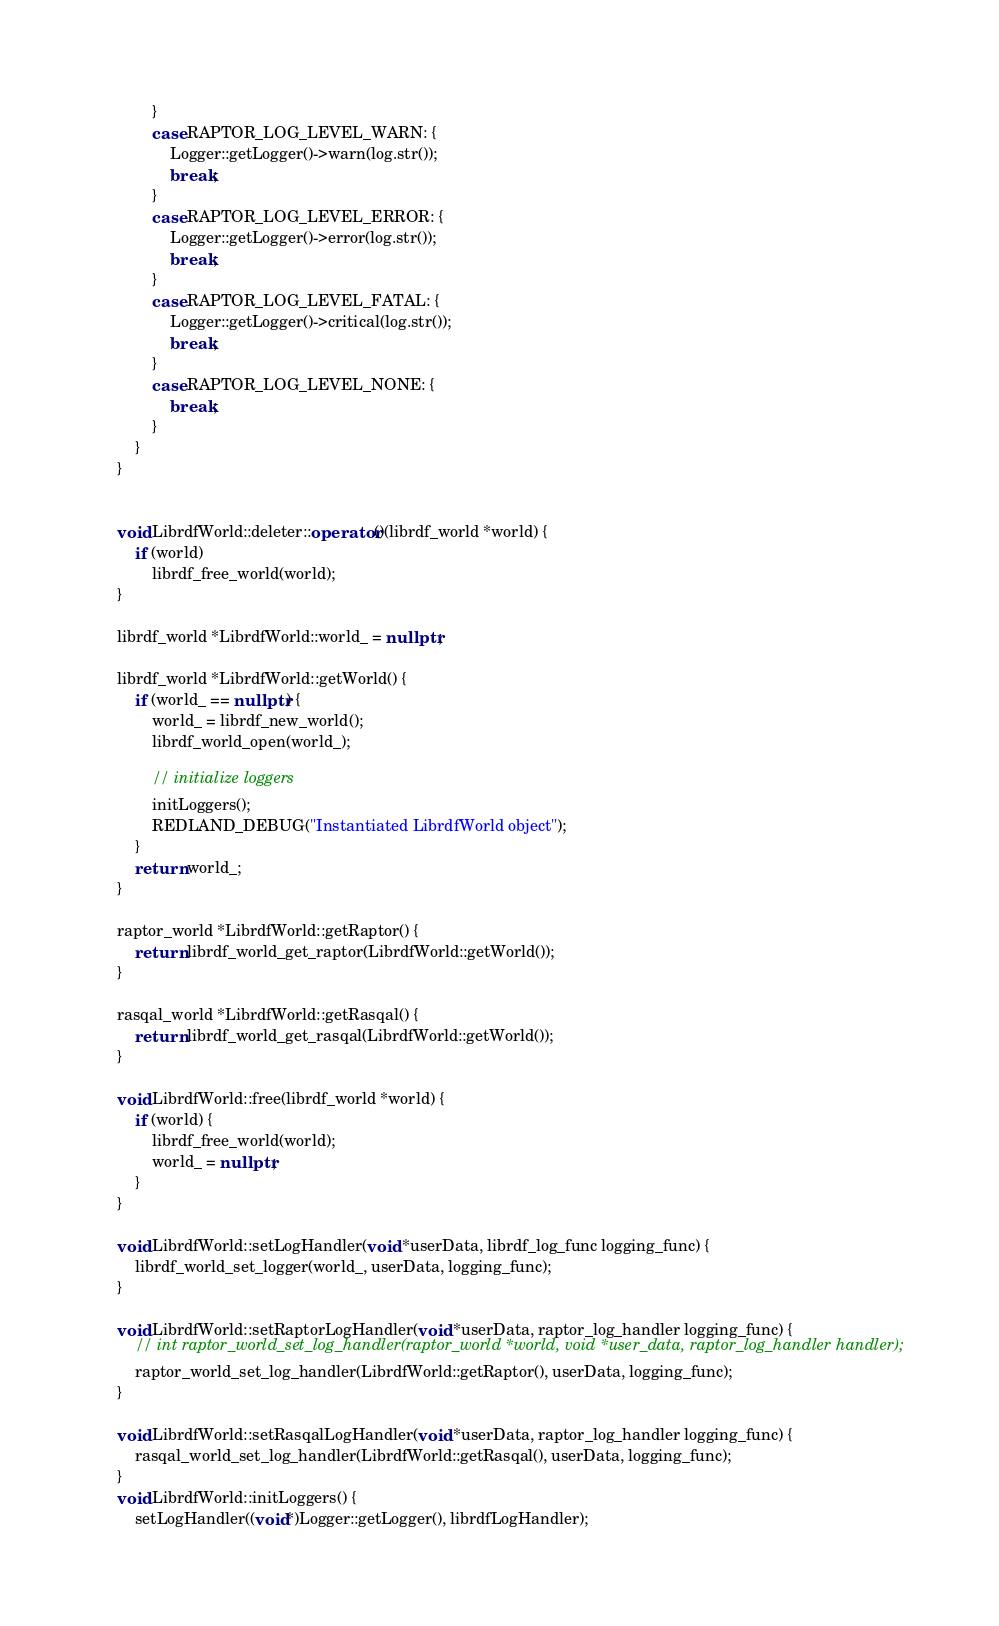Convert code to text. <code><loc_0><loc_0><loc_500><loc_500><_C++_>            }
            case RAPTOR_LOG_LEVEL_WARN: {
                Logger::getLogger()->warn(log.str());
                break;
            }
            case RAPTOR_LOG_LEVEL_ERROR: {
                Logger::getLogger()->error(log.str());
                break;
            }
            case RAPTOR_LOG_LEVEL_FATAL: {
                Logger::getLogger()->critical(log.str());
                break;
            }
            case RAPTOR_LOG_LEVEL_NONE: {
                break;
            }
        }
    }


    void LibrdfWorld::deleter::operator()(librdf_world *world) {
        if (world)
            librdf_free_world(world);
    }

    librdf_world *LibrdfWorld::world_ = nullptr;

    librdf_world *LibrdfWorld::getWorld() {
        if (world_ == nullptr) {
            world_ = librdf_new_world();
            librdf_world_open(world_);

            // initialize loggers
            initLoggers();
            REDLAND_DEBUG("Instantiated LibrdfWorld object");
        }
        return world_;
    }

    raptor_world *LibrdfWorld::getRaptor() {
        return librdf_world_get_raptor(LibrdfWorld::getWorld());
    }

    rasqal_world *LibrdfWorld::getRasqal() {
        return librdf_world_get_rasqal(LibrdfWorld::getWorld());
    }

    void LibrdfWorld::free(librdf_world *world) {
        if (world) {
            librdf_free_world(world);
            world_ = nullptr;
        }
    }

    void LibrdfWorld::setLogHandler(void *userData, librdf_log_func logging_func) {
        librdf_world_set_logger(world_, userData, logging_func);
    }

    void LibrdfWorld::setRaptorLogHandler(void *userData, raptor_log_handler logging_func) {
        // int raptor_world_set_log_handler(raptor_world *world, void *user_data, raptor_log_handler handler);
        raptor_world_set_log_handler(LibrdfWorld::getRaptor(), userData, logging_func);
    }

    void LibrdfWorld::setRasqalLogHandler(void *userData, raptor_log_handler logging_func) {
        rasqal_world_set_log_handler(LibrdfWorld::getRasqal(), userData, logging_func);
    }
    void LibrdfWorld::initLoggers() {
        setLogHandler((void*)Logger::getLogger(), librdfLogHandler);</code> 